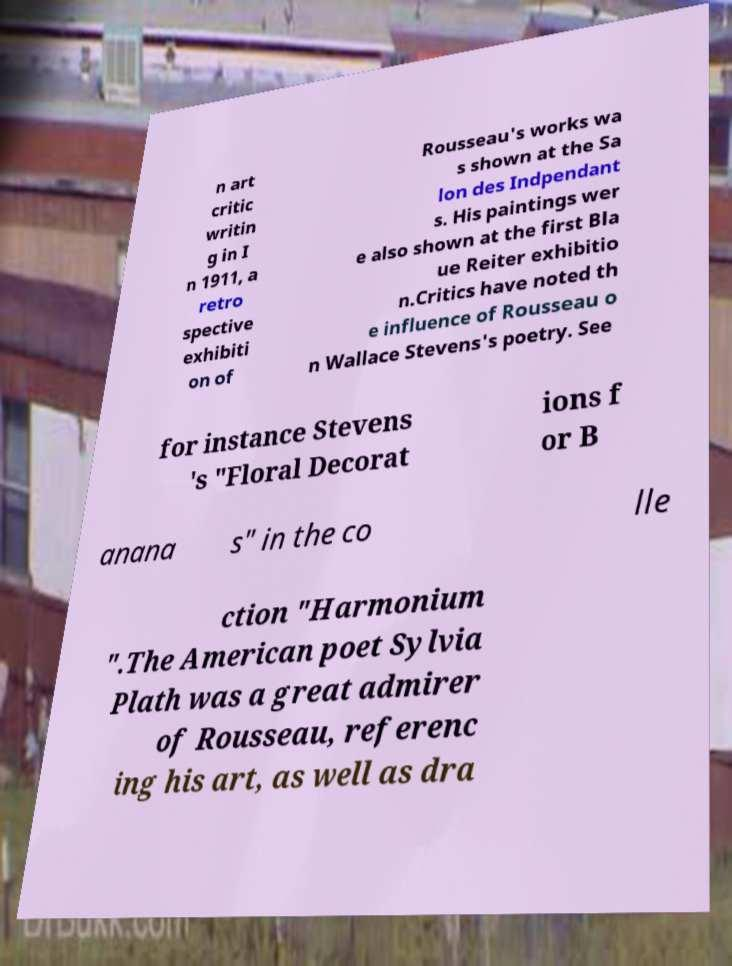Can you accurately transcribe the text from the provided image for me? n art critic writin g in I n 1911, a retro spective exhibiti on of Rousseau's works wa s shown at the Sa lon des Indpendant s. His paintings wer e also shown at the first Bla ue Reiter exhibitio n.Critics have noted th e influence of Rousseau o n Wallace Stevens's poetry. See for instance Stevens 's "Floral Decorat ions f or B anana s" in the co lle ction "Harmonium ".The American poet Sylvia Plath was a great admirer of Rousseau, referenc ing his art, as well as dra 